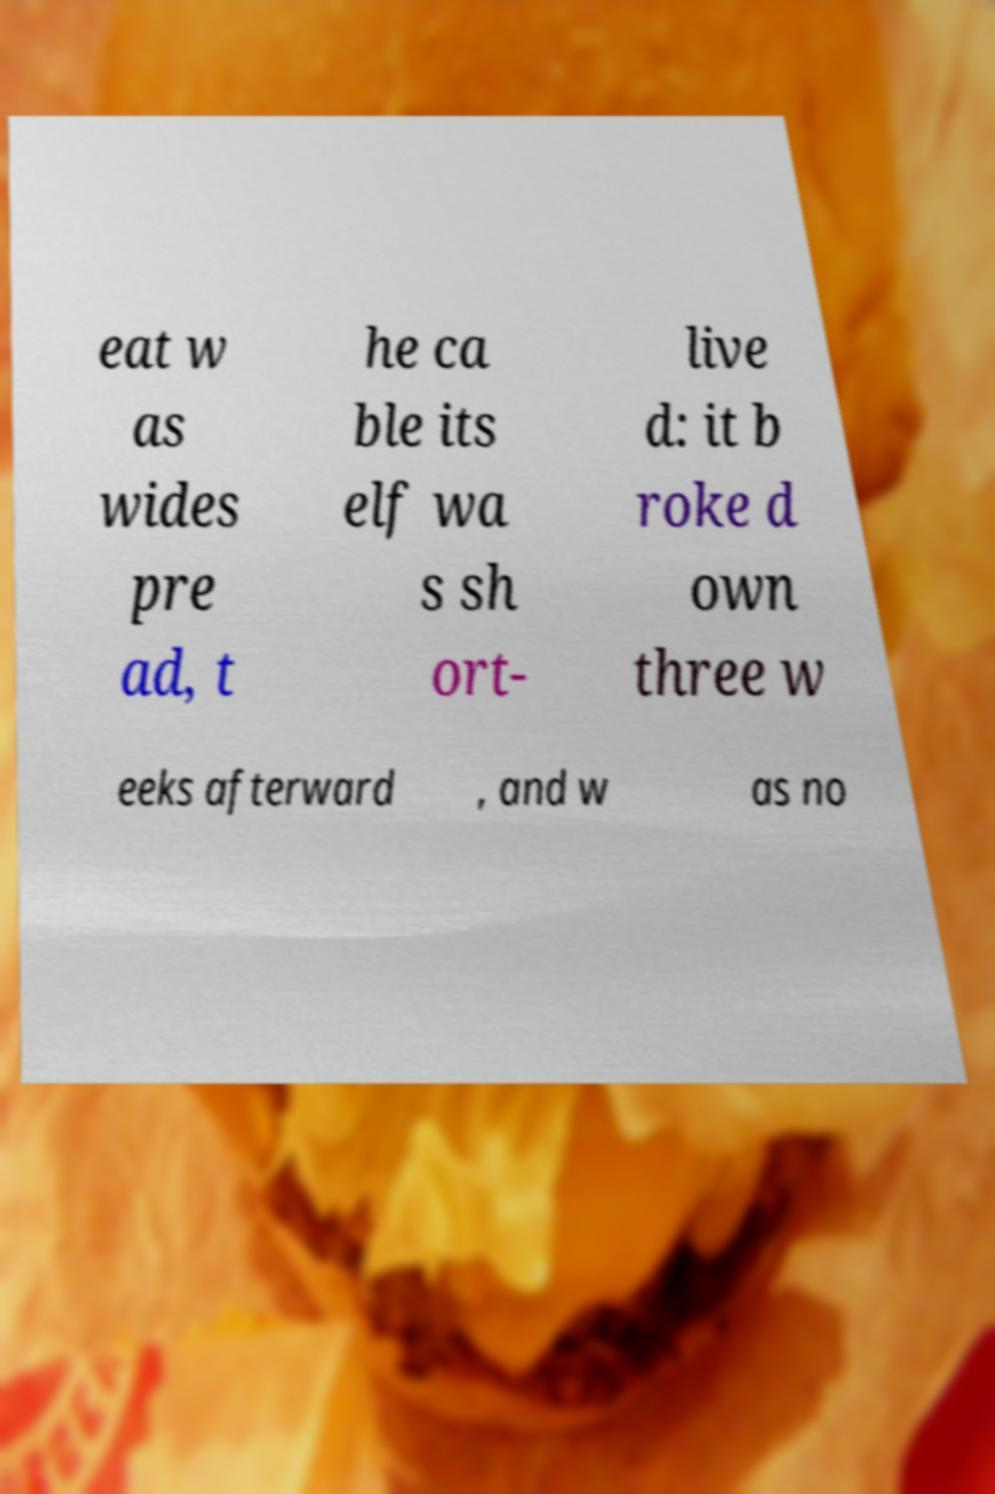Please read and relay the text visible in this image. What does it say? eat w as wides pre ad, t he ca ble its elf wa s sh ort- live d: it b roke d own three w eeks afterward , and w as no 